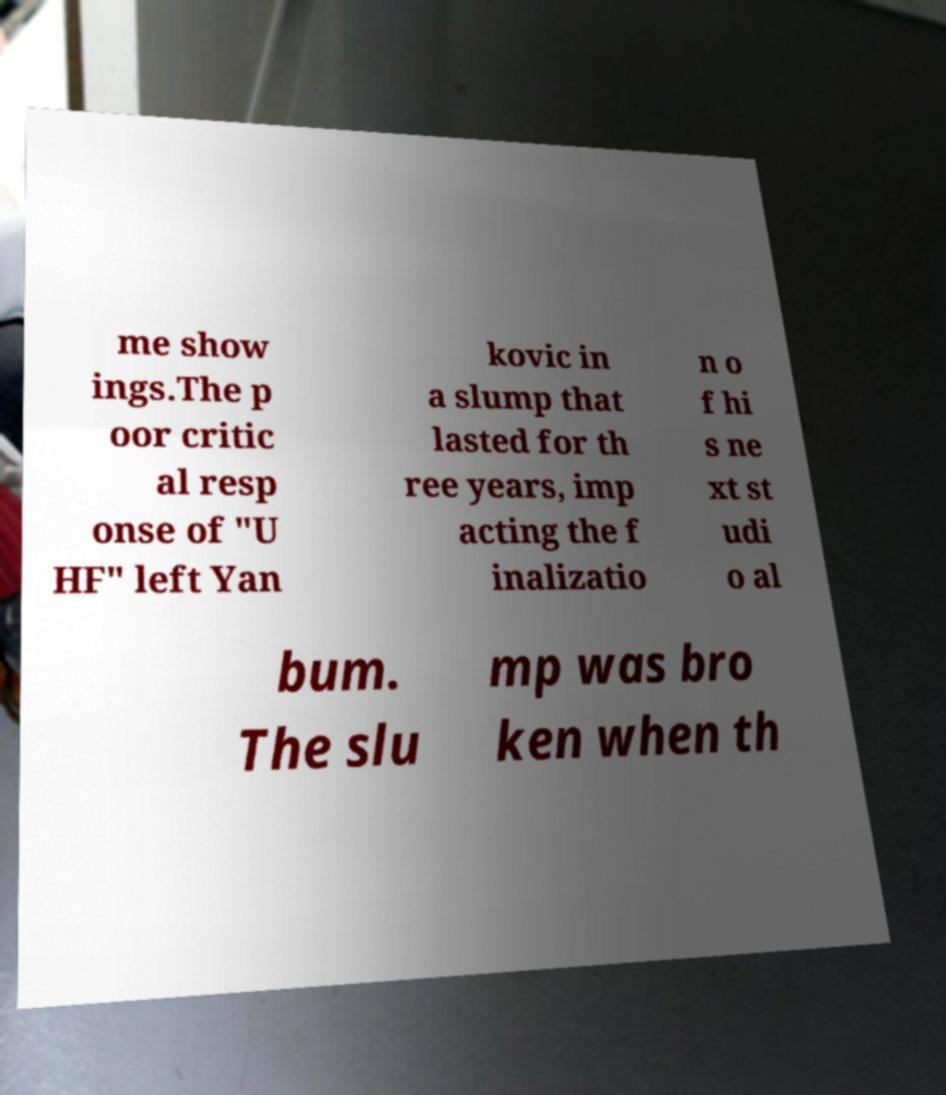There's text embedded in this image that I need extracted. Can you transcribe it verbatim? me show ings.The p oor critic al resp onse of "U HF" left Yan kovic in a slump that lasted for th ree years, imp acting the f inalizatio n o f hi s ne xt st udi o al bum. The slu mp was bro ken when th 